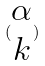Convert formula to latex. <formula><loc_0><loc_0><loc_500><loc_500>( \begin{matrix} \alpha \\ k \end{matrix} )</formula> 